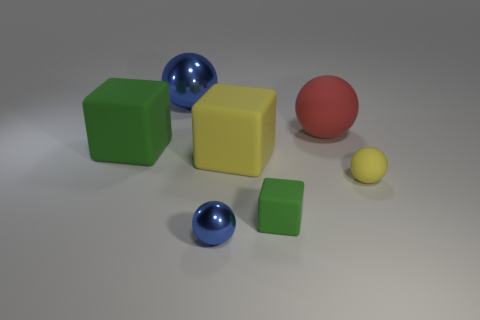Subtract all large rubber cubes. How many cubes are left? 1 Subtract all red balls. How many balls are left? 3 Subtract all gray spheres. Subtract all green cylinders. How many spheres are left? 4 Add 2 big blue spheres. How many objects exist? 9 Add 7 yellow balls. How many yellow balls are left? 8 Add 7 tiny green metal objects. How many tiny green metal objects exist? 7 Subtract 0 green cylinders. How many objects are left? 7 Subtract all blocks. How many objects are left? 4 Subtract all large green things. Subtract all small blocks. How many objects are left? 5 